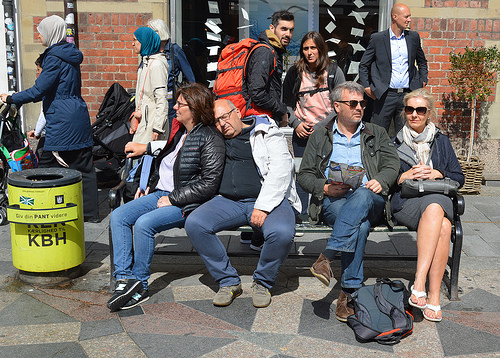<image>
Is the man to the left of the garbage? No. The man is not to the left of the garbage. From this viewpoint, they have a different horizontal relationship. Is there a man behind the woman? No. The man is not behind the woman. From this viewpoint, the man appears to be positioned elsewhere in the scene. Is there a backpack in front of the man? Yes. The backpack is positioned in front of the man, appearing closer to the camera viewpoint. 